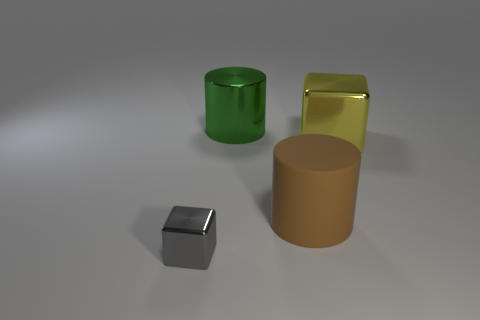The big shiny thing in front of the green metallic cylinder has what shape?
Ensure brevity in your answer.  Cube. What number of big objects are both to the right of the big matte cylinder and behind the yellow object?
Make the answer very short. 0. Is there another small gray thing made of the same material as the small object?
Ensure brevity in your answer.  No. What number of blocks are either yellow metallic objects or small cyan matte objects?
Offer a terse response. 1. What size is the green shiny cylinder?
Provide a short and direct response. Large. What number of large yellow objects are right of the green metallic object?
Your answer should be very brief. 1. There is a metal block that is behind the thing that is left of the big green cylinder; what size is it?
Your answer should be very brief. Large. Is the shape of the object behind the large yellow shiny object the same as the large thing that is in front of the big cube?
Your answer should be compact. Yes. There is a large shiny object that is behind the metal object on the right side of the green shiny cylinder; what is its shape?
Give a very brief answer. Cylinder. What is the size of the thing that is both behind the gray metallic cube and on the left side of the large rubber object?
Your answer should be very brief. Large. 